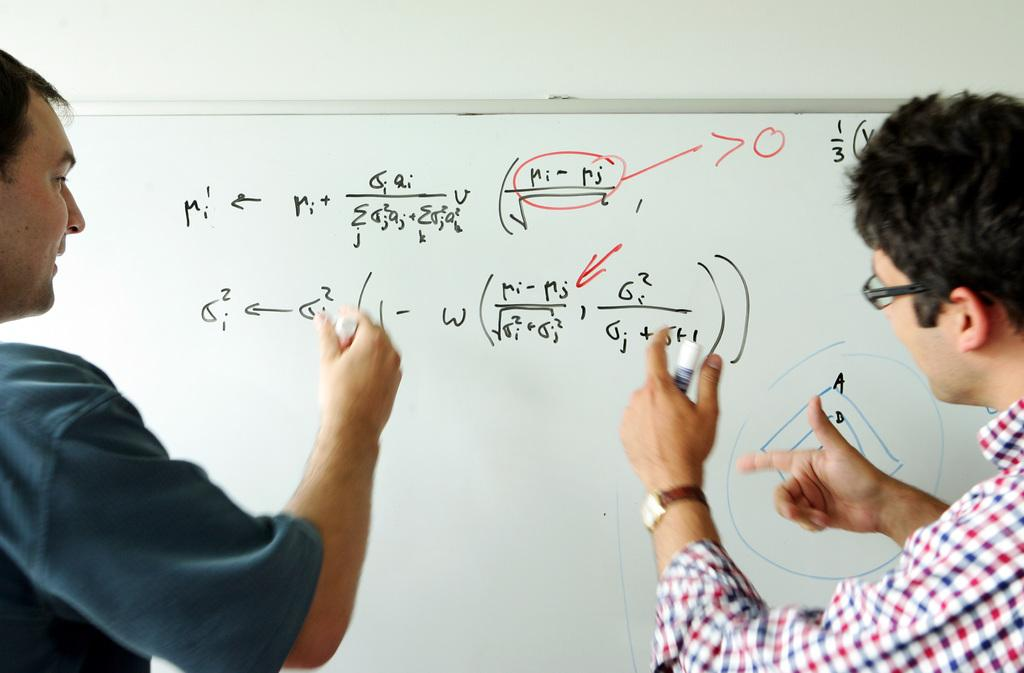<image>
Create a compact narrative representing the image presented. A whiteboard with math problems that include ri-rj. 